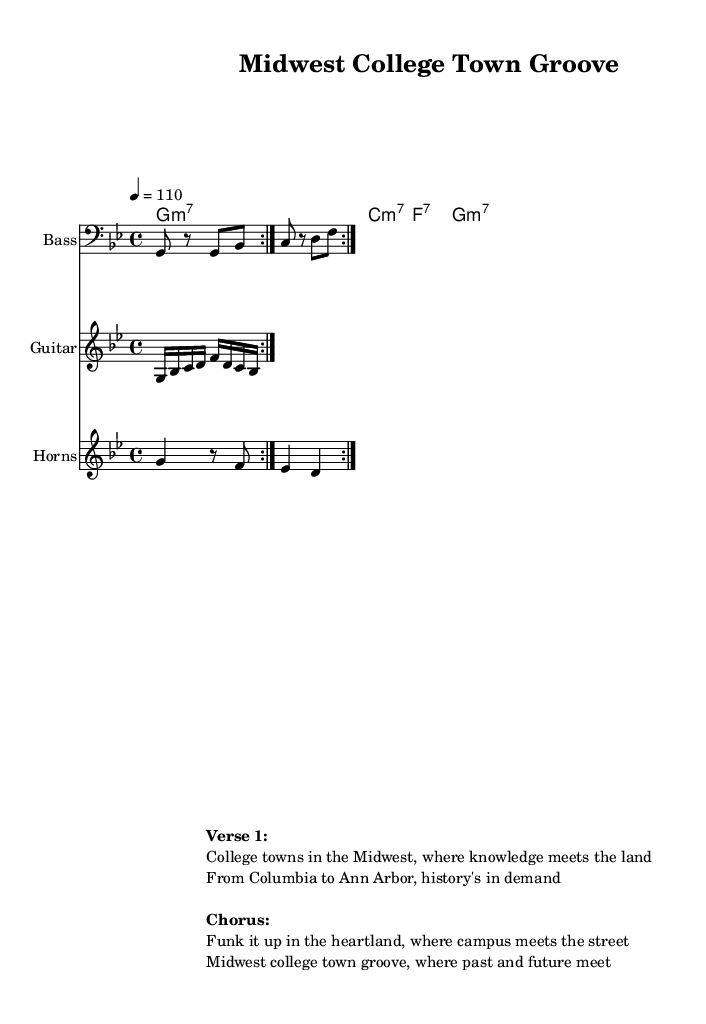What is the key signature of this music? The key signature is G minor, as indicated by the 'g' at the beginning and the presence of two flats.
Answer: G minor What is the time signature of this music? The time signature is 4/4, shown as a fraction at the beginning of the sheet music.
Answer: 4/4 What is the tempo marking for this piece? The tempo marking indicates a speed of 110 beats per minute, represented by the notation "4 = 110".
Answer: 110 How many measures are repeated in the bass line? The bass line is marked with a 'Volta' indicating it is to be repeated twice.
Answer: 2 What is the function of the guitar part in this composition? The guitar part provides a rhythmic and melodic riff that complements the bass and horn sections, typical in funk music to enhance groove.
Answer: Riff What is the primary theme expressed in the lyrics? The primary theme explores the connection between college towns' history and their cultural evolution, emphasizing educational value.
Answer: College towns Which style of music is represented in this score? The style of music represented is Funk, evident from the groove-oriented rhythmic patterns and upbeat tempo.
Answer: Funk 